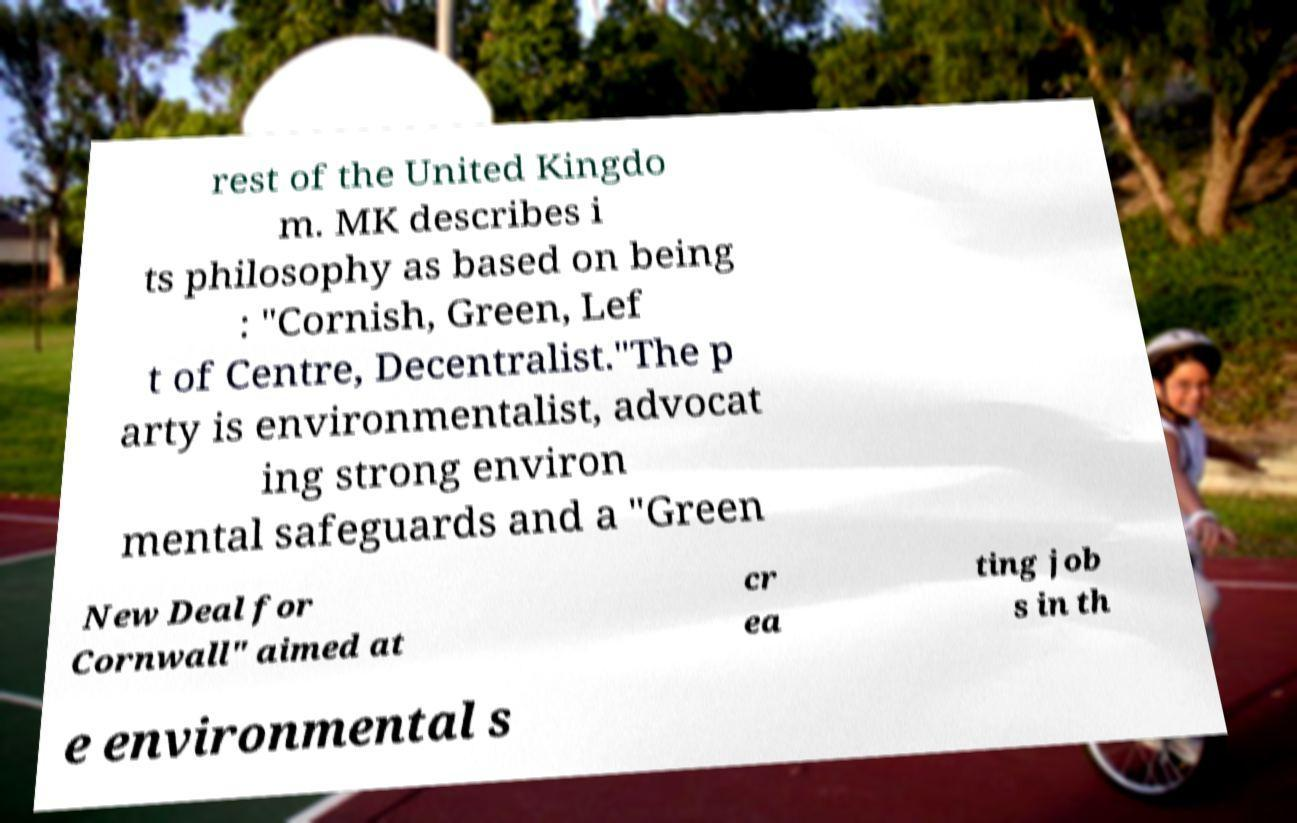There's text embedded in this image that I need extracted. Can you transcribe it verbatim? rest of the United Kingdo m. MK describes i ts philosophy as based on being : "Cornish, Green, Lef t of Centre, Decentralist."The p arty is environmentalist, advocat ing strong environ mental safeguards and a "Green New Deal for Cornwall" aimed at cr ea ting job s in th e environmental s 